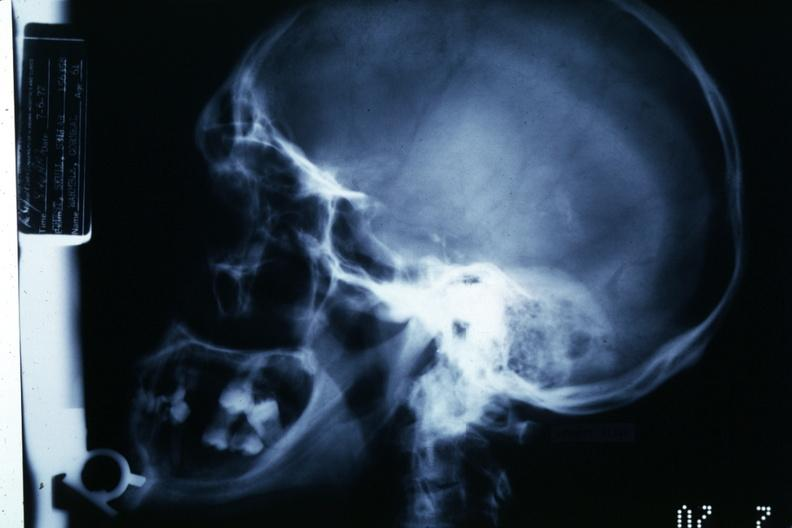s hemisection of nose present?
Answer the question using a single word or phrase. No 